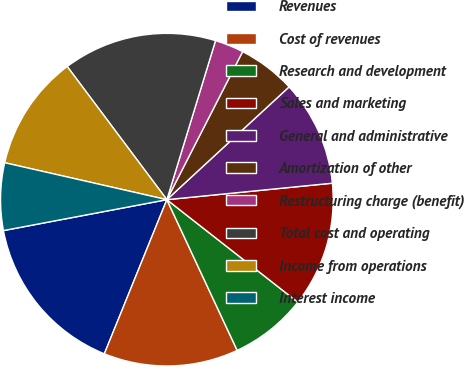Convert chart. <chart><loc_0><loc_0><loc_500><loc_500><pie_chart><fcel>Revenues<fcel>Cost of revenues<fcel>Research and development<fcel>Sales and marketing<fcel>General and administrative<fcel>Amortization of other<fcel>Restructuring charge (benefit)<fcel>Total cost and operating<fcel>Income from operations<fcel>Interest income<nl><fcel>15.89%<fcel>13.08%<fcel>7.48%<fcel>12.15%<fcel>10.28%<fcel>5.61%<fcel>2.8%<fcel>14.95%<fcel>11.21%<fcel>6.54%<nl></chart> 